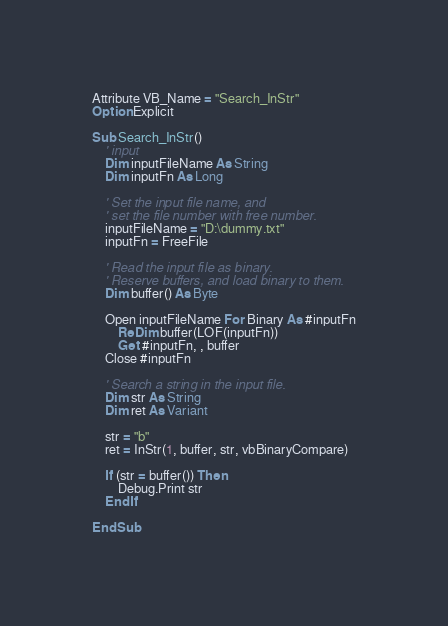Convert code to text. <code><loc_0><loc_0><loc_500><loc_500><_VisualBasic_>Attribute VB_Name = "Search_InStr"
Option Explicit

Sub Search_InStr()
    ' input
    Dim inputFileName As String
    Dim inputFn As Long

    ' Set the input file name, and
    ' set the file number with free number.
    inputFileName = "D:\dummy.txt"
    inputFn = FreeFile

    ' Read the input file as binary.
    ' Reserve buffers, and load binary to them.
    Dim buffer() As Byte

    Open inputFileName For Binary As #inputFn
        ReDim buffer(LOF(inputFn))
        Get #inputFn, , buffer
    Close #inputFn

    ' Search a string in the input file.
    Dim str As String
    Dim ret As Variant

    str = "b"
    ret = InStr(1, buffer, str, vbBinaryCompare)
    
    If (str = buffer()) Then
        Debug.Print str
    End If

End Sub
</code> 